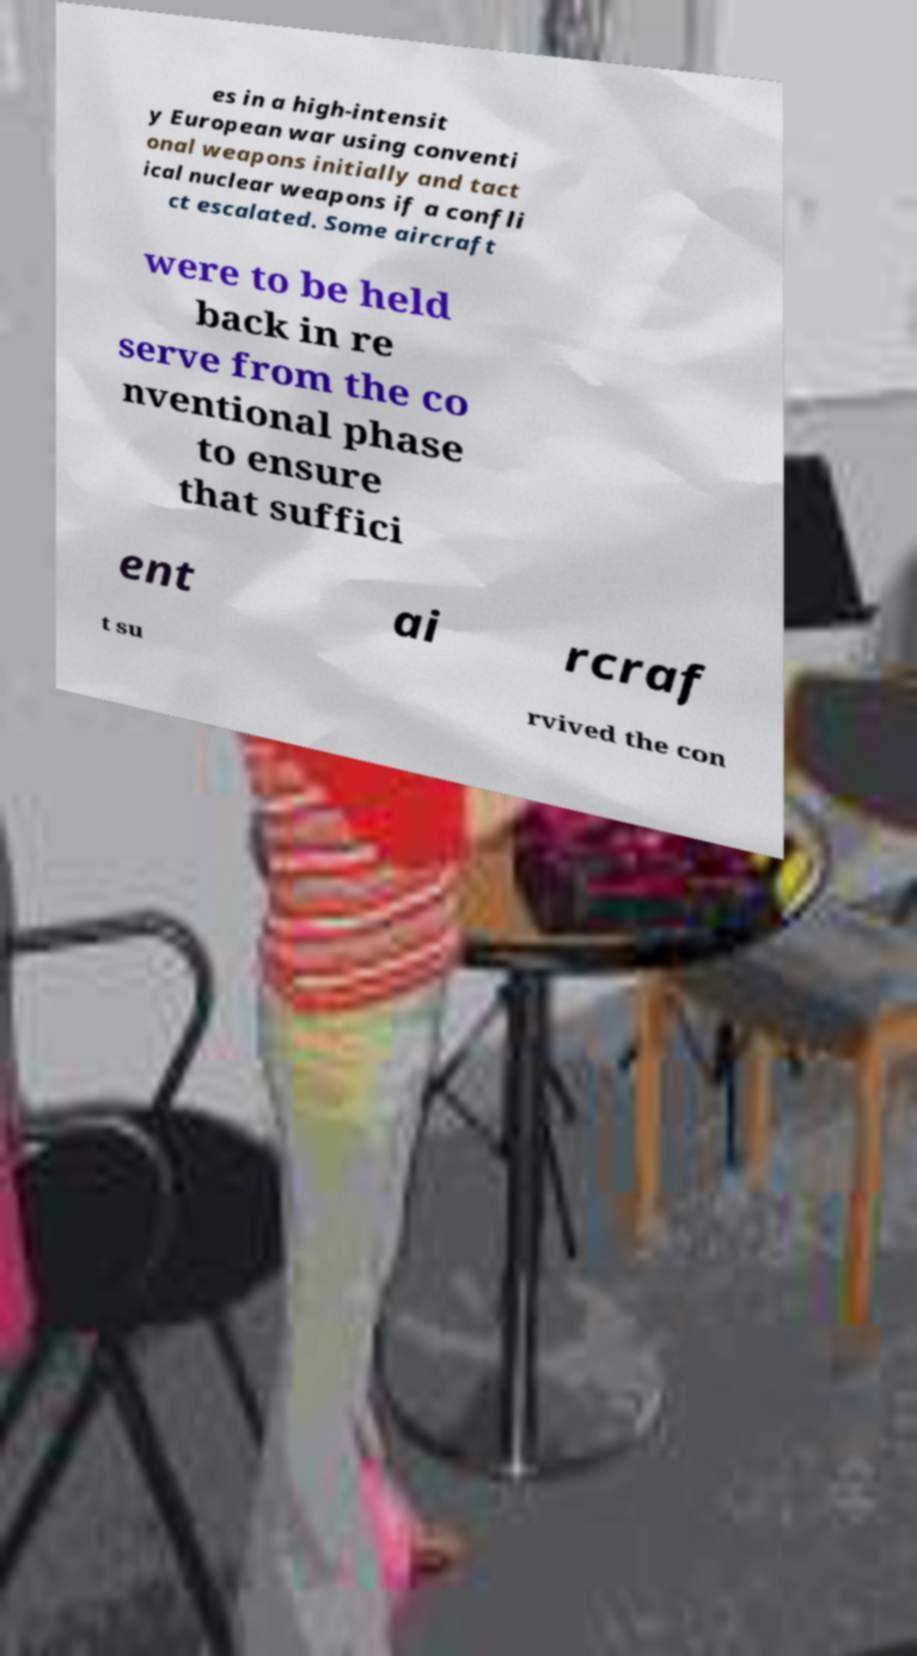There's text embedded in this image that I need extracted. Can you transcribe it verbatim? es in a high-intensit y European war using conventi onal weapons initially and tact ical nuclear weapons if a confli ct escalated. Some aircraft were to be held back in re serve from the co nventional phase to ensure that suffici ent ai rcraf t su rvived the con 